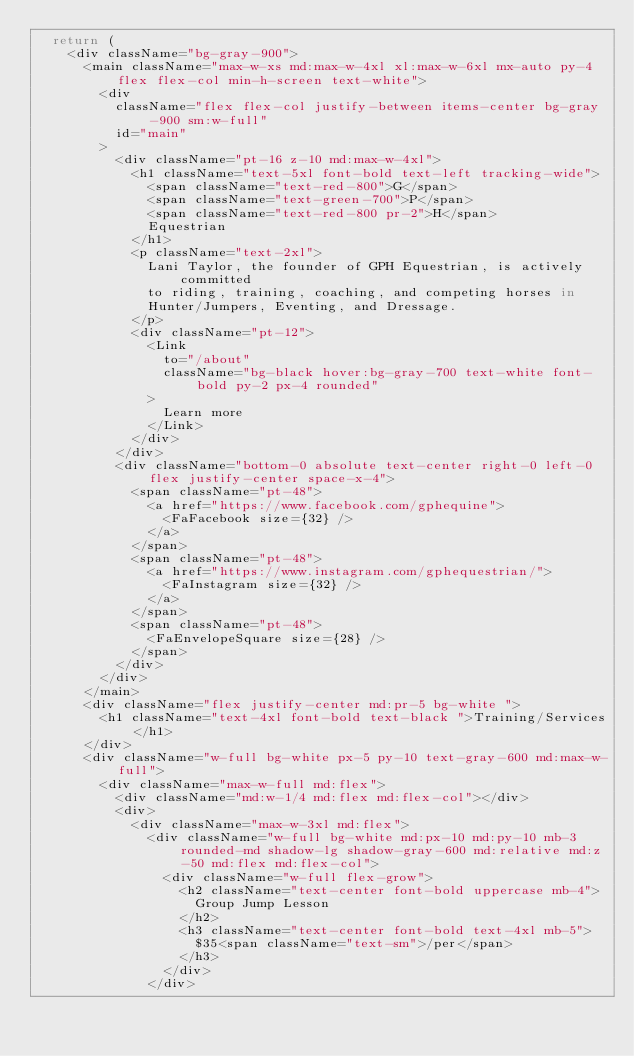<code> <loc_0><loc_0><loc_500><loc_500><_JavaScript_>  return (
    <div className="bg-gray-900">
      <main className="max-w-xs md:max-w-4xl xl:max-w-6xl mx-auto py-4 flex flex-col min-h-screen text-white">
        <div
          className="flex flex-col justify-between items-center bg-gray-900 sm:w-full"
          id="main"
        >
          <div className="pt-16 z-10 md:max-w-4xl">
            <h1 className="text-5xl font-bold text-left tracking-wide">
              <span className="text-red-800">G</span>
              <span className="text-green-700">P</span>
              <span className="text-red-800 pr-2">H</span>
              Equestrian
            </h1>
            <p className="text-2xl">
              Lani Taylor, the founder of GPH Equestrian, is actively committed
              to riding, training, coaching, and competing horses in
              Hunter/Jumpers, Eventing, and Dressage.
            </p>
            <div className="pt-12">
              <Link
                to="/about"
                className="bg-black hover:bg-gray-700 text-white font-bold py-2 px-4 rounded"
              >
                Learn more
              </Link>
            </div>
          </div>
          <div className="bottom-0 absolute text-center right-0 left-0 flex justify-center space-x-4">
            <span className="pt-48">
              <a href="https://www.facebook.com/gphequine">
                <FaFacebook size={32} />
              </a>
            </span>
            <span className="pt-48">
              <a href="https://www.instagram.com/gphequestrian/">
                <FaInstagram size={32} />
              </a>
            </span>
            <span className="pt-48">
              <FaEnvelopeSquare size={28} />
            </span>
          </div>
        </div>
      </main>
      <div className="flex justify-center md:pr-5 bg-white ">
        <h1 className="text-4xl font-bold text-black ">Training/Services</h1>
      </div>
      <div className="w-full bg-white px-5 py-10 text-gray-600 md:max-w-full">
        <div className="max-w-full md:flex">
          <div className="md:w-1/4 md:flex md:flex-col"></div>
          <div>
            <div className="max-w-3xl md:flex">
              <div className="w-full bg-white md:px-10 md:py-10 mb-3 rounded-md shadow-lg shadow-gray-600 md:relative md:z-50 md:flex md:flex-col">
                <div className="w-full flex-grow">
                  <h2 className="text-center font-bold uppercase mb-4">
                    Group Jump Lesson
                  </h2>
                  <h3 className="text-center font-bold text-4xl mb-5">
                    $35<span className="text-sm">/per</span>
                  </h3>
                </div>
              </div></code> 